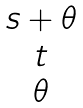<formula> <loc_0><loc_0><loc_500><loc_500>\begin{matrix} s + \theta \\ t \\ \theta \end{matrix}</formula> 